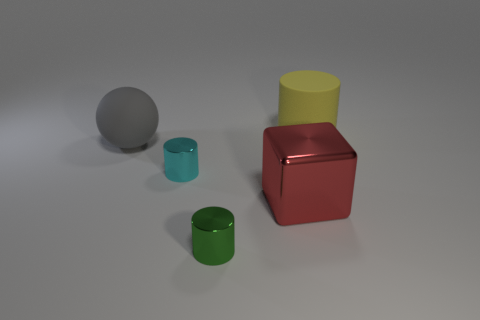Subtract all tiny cylinders. How many cylinders are left? 1 Subtract all cyan cylinders. How many cylinders are left? 2 Add 4 small purple rubber cylinders. How many objects exist? 9 Subtract all purple cylinders. Subtract all blue spheres. How many cylinders are left? 3 Subtract all green cubes. How many cyan cylinders are left? 1 Subtract all matte spheres. Subtract all cyan objects. How many objects are left? 3 Add 2 matte objects. How many matte objects are left? 4 Add 3 tiny green things. How many tiny green things exist? 4 Subtract 0 purple blocks. How many objects are left? 5 Subtract all cylinders. How many objects are left? 2 